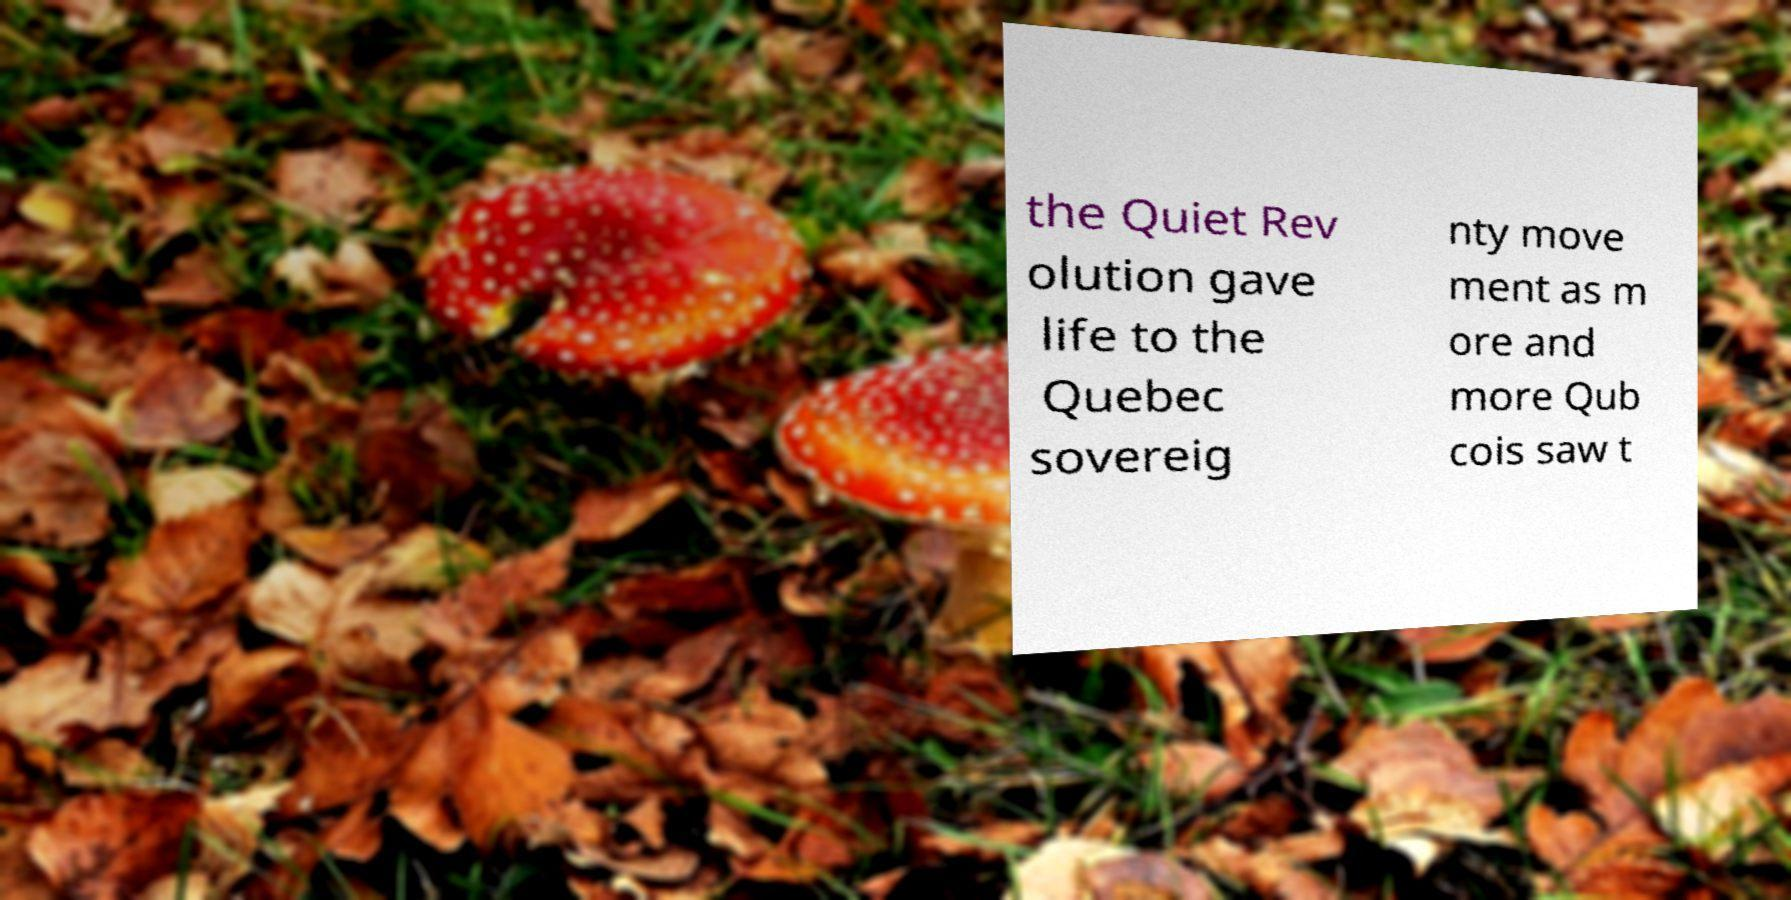For documentation purposes, I need the text within this image transcribed. Could you provide that? the Quiet Rev olution gave life to the Quebec sovereig nty move ment as m ore and more Qub cois saw t 